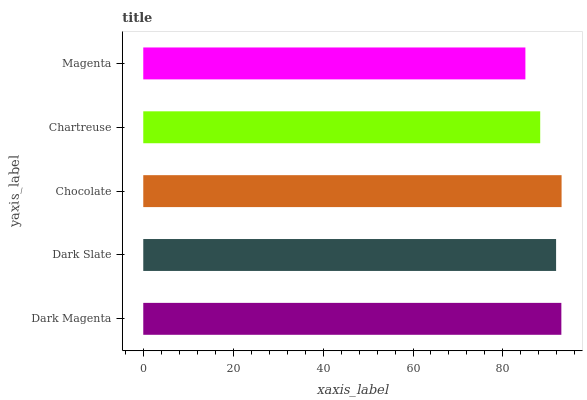Is Magenta the minimum?
Answer yes or no. Yes. Is Chocolate the maximum?
Answer yes or no. Yes. Is Dark Slate the minimum?
Answer yes or no. No. Is Dark Slate the maximum?
Answer yes or no. No. Is Dark Magenta greater than Dark Slate?
Answer yes or no. Yes. Is Dark Slate less than Dark Magenta?
Answer yes or no. Yes. Is Dark Slate greater than Dark Magenta?
Answer yes or no. No. Is Dark Magenta less than Dark Slate?
Answer yes or no. No. Is Dark Slate the high median?
Answer yes or no. Yes. Is Dark Slate the low median?
Answer yes or no. Yes. Is Dark Magenta the high median?
Answer yes or no. No. Is Chocolate the low median?
Answer yes or no. No. 